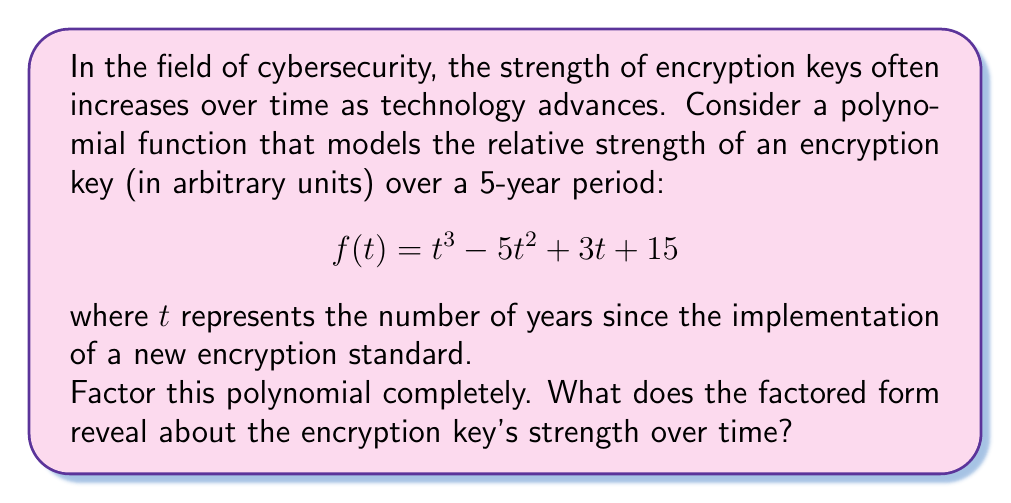Teach me how to tackle this problem. Let's approach this step-by-step:

1) First, we need to check if there are any rational roots. We can use the rational root theorem. The possible rational roots are the factors of the constant term (15): ±1, ±3, ±5, ±15.

2) Testing these values, we find that $t = 3$ is a root of the polynomial.

3) We can factor out $(t - 3)$:

   $$f(t) = (t - 3)(t^2 - 2t - 5)$$

4) Now we need to factor the quadratic term $t^2 - 2t - 5$. We can use the quadratic formula or factoring by grouping.

5) Using the quadratic formula: $t = \frac{-b \pm \sqrt{b^2 - 4ac}}{2a}$
   
   Here, $a=1$, $b=-2$, and $c=-5$

   $$t = \frac{2 \pm \sqrt{4 + 20}}{2} = \frac{2 \pm \sqrt{24}}{2} = \frac{2 \pm 2\sqrt{6}}{2}$$

6) This gives us the roots: $t = 1 + \sqrt{6}$ and $t = 1 - \sqrt{6}$

7) Therefore, the fully factored polynomial is:

   $$f(t) = (t - 3)(t - (1 + \sqrt{6}))(t - (1 - \sqrt{6}))$$

This factored form reveals that the encryption key strength has three critical points over time:

- At $t = 3$ years, there's a significant change in key strength.
- At $t \approx 1 + \sqrt{6} \approx 3.45$ years, there's another critical point.
- At $t \approx 1 - \sqrt{6} \approx -1.45$ years (which is before the new standard was implemented), there's a theoretical critical point.

The presence of irrational roots suggests that the key strength doesn't follow a simple linear pattern, but has complex behavior over time.
Answer: $$f(t) = (t - 3)(t - (1 + \sqrt{6}))(t - (1 - \sqrt{6}))$$ 